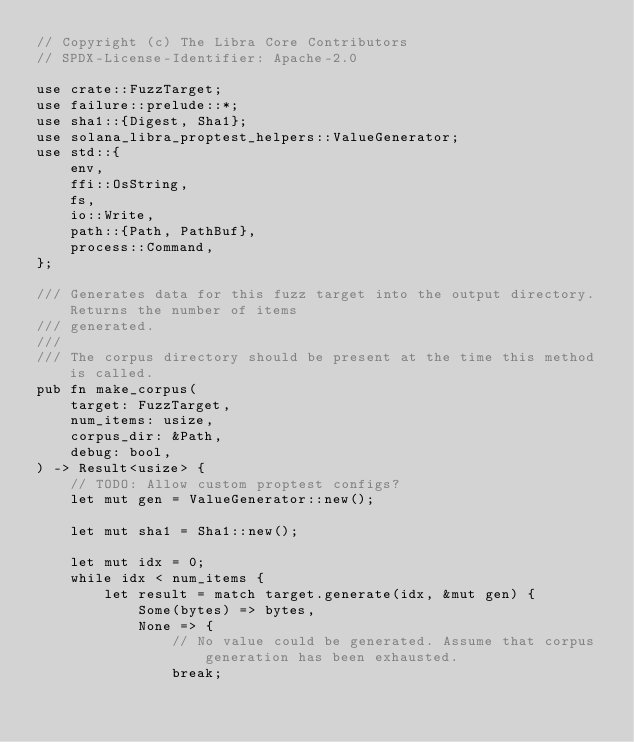<code> <loc_0><loc_0><loc_500><loc_500><_Rust_>// Copyright (c) The Libra Core Contributors
// SPDX-License-Identifier: Apache-2.0

use crate::FuzzTarget;
use failure::prelude::*;
use sha1::{Digest, Sha1};
use solana_libra_proptest_helpers::ValueGenerator;
use std::{
    env,
    ffi::OsString,
    fs,
    io::Write,
    path::{Path, PathBuf},
    process::Command,
};

/// Generates data for this fuzz target into the output directory. Returns the number of items
/// generated.
///
/// The corpus directory should be present at the time this method is called.
pub fn make_corpus(
    target: FuzzTarget,
    num_items: usize,
    corpus_dir: &Path,
    debug: bool,
) -> Result<usize> {
    // TODO: Allow custom proptest configs?
    let mut gen = ValueGenerator::new();

    let mut sha1 = Sha1::new();

    let mut idx = 0;
    while idx < num_items {
        let result = match target.generate(idx, &mut gen) {
            Some(bytes) => bytes,
            None => {
                // No value could be generated. Assume that corpus generation has been exhausted.
                break;</code> 